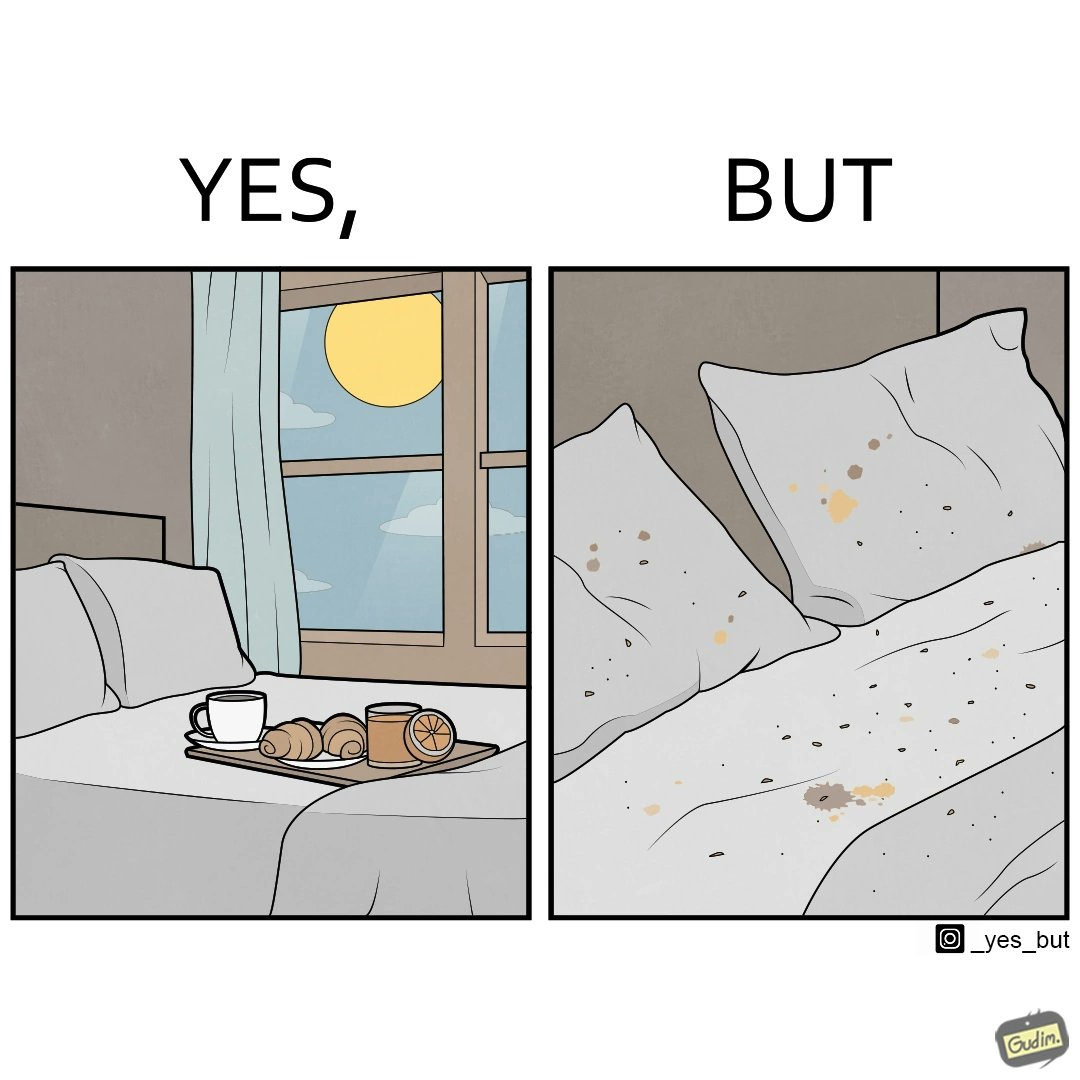Describe the contrast between the left and right parts of this image. In the left part of the image: Breakfast on bed In the right part of the image: Food crumbs on bed 